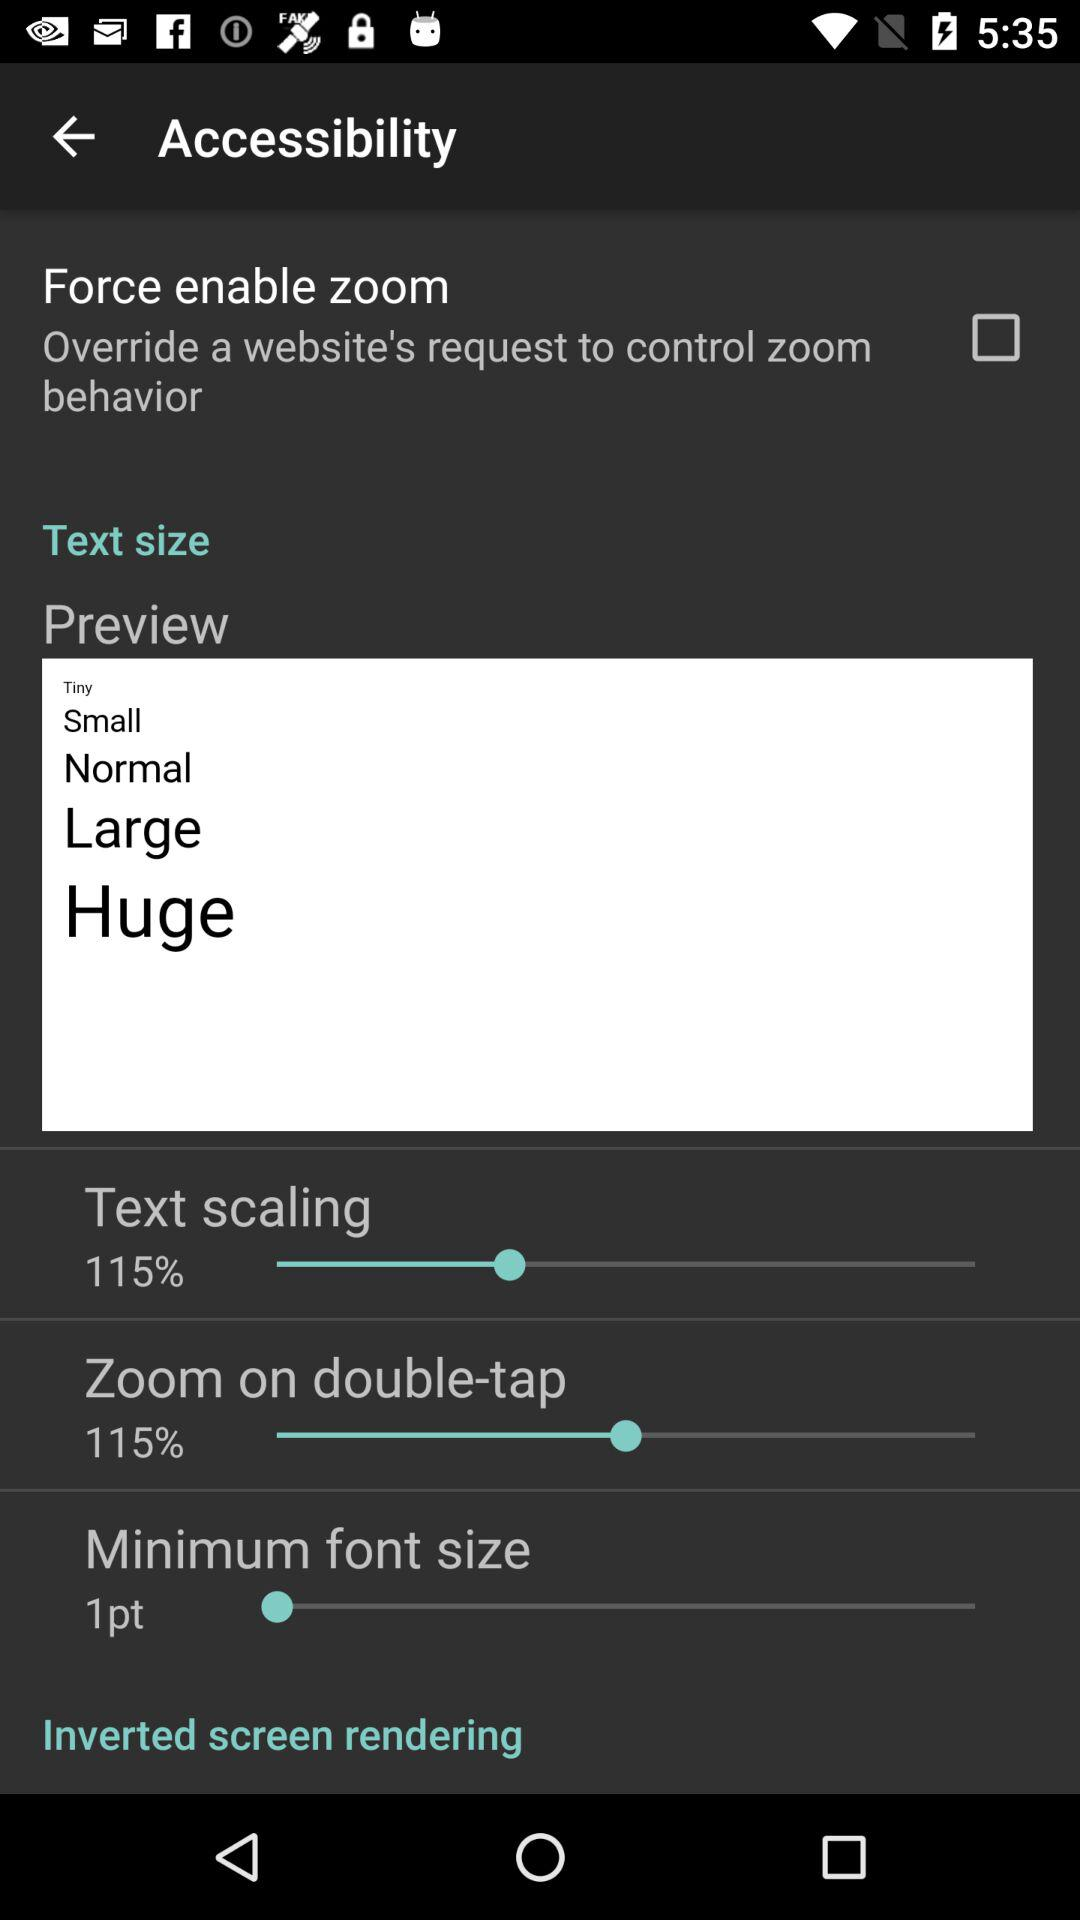What is the percentage of zoom on double-tap? The percentage of zoom on double-tap is 115. 